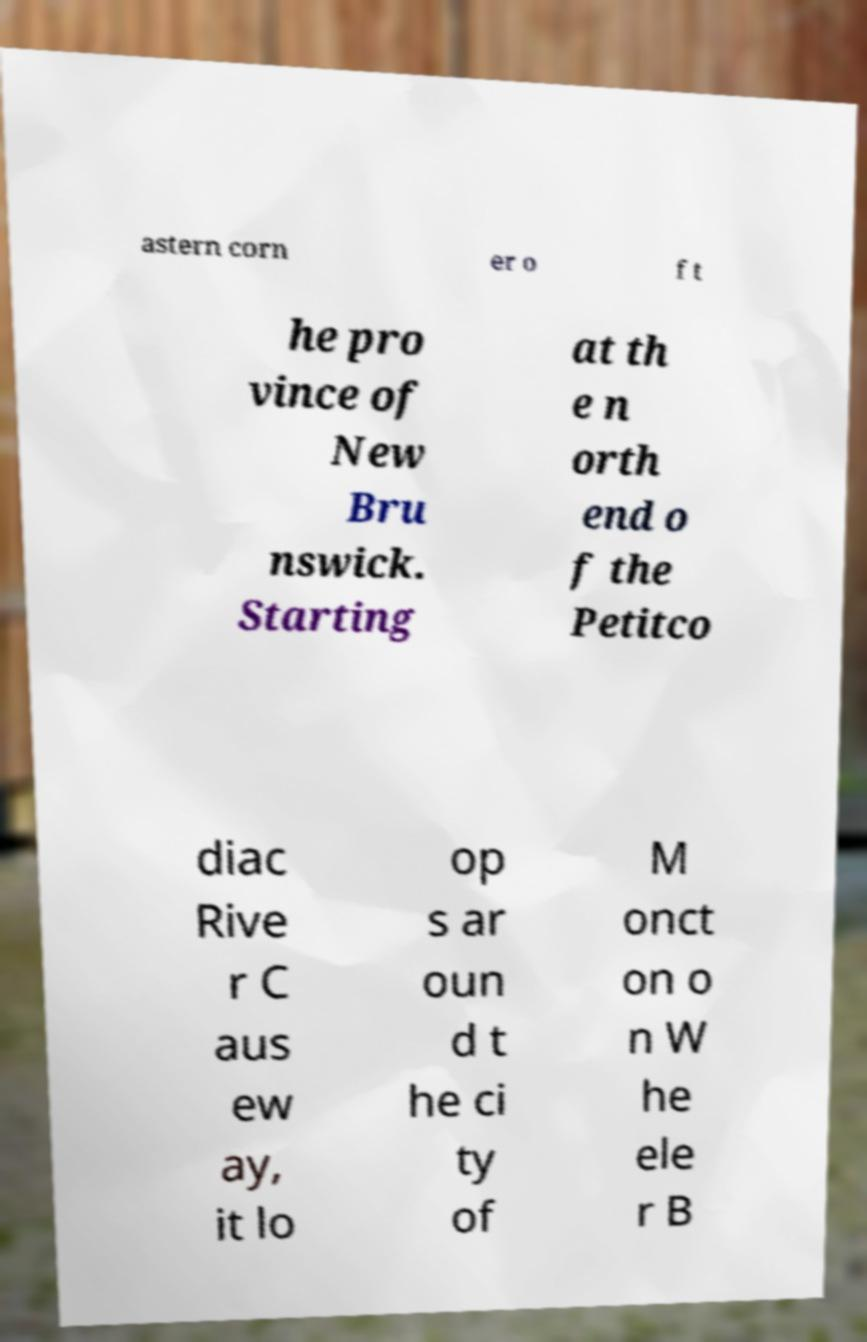Please identify and transcribe the text found in this image. astern corn er o f t he pro vince of New Bru nswick. Starting at th e n orth end o f the Petitco diac Rive r C aus ew ay, it lo op s ar oun d t he ci ty of M onct on o n W he ele r B 